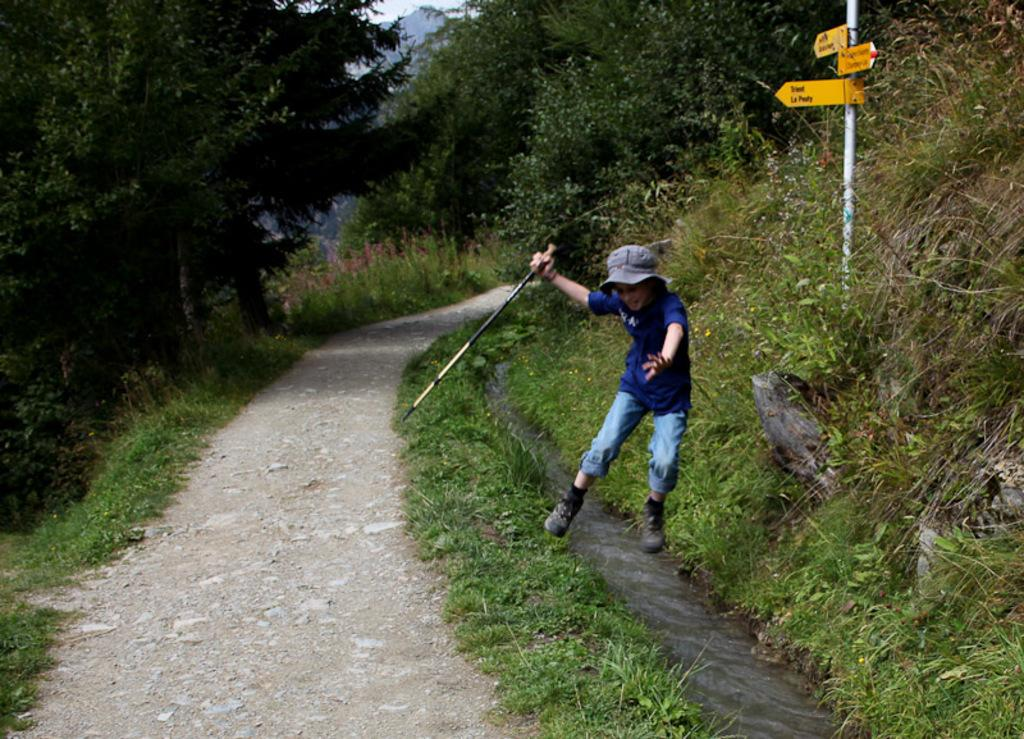What type of vegetation is present in the image? There is grass, plants, and trees in the image. What else can be seen in the image besides vegetation? There is a sign pole and a boy in the image. What is the boy doing in the image? The boy is holding a stick in his hand. What type of jeans is the boy wearing in the image? The image does not provide information about the boy's clothing, so we cannot determine if he is wearing jeans or any other type of clothing. What type of oatmeal can be seen in the image? There is no oatmeal present in the image. 